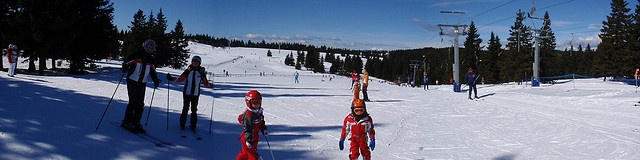Describe the objects in this image and their specific colors. I can see people in black, navy, gray, and darkblue tones, people in black, maroon, brown, and lightgray tones, people in black, navy, darkblue, and gray tones, people in black, maroon, brown, and gray tones, and people in black, lightgray, navy, and gray tones in this image. 